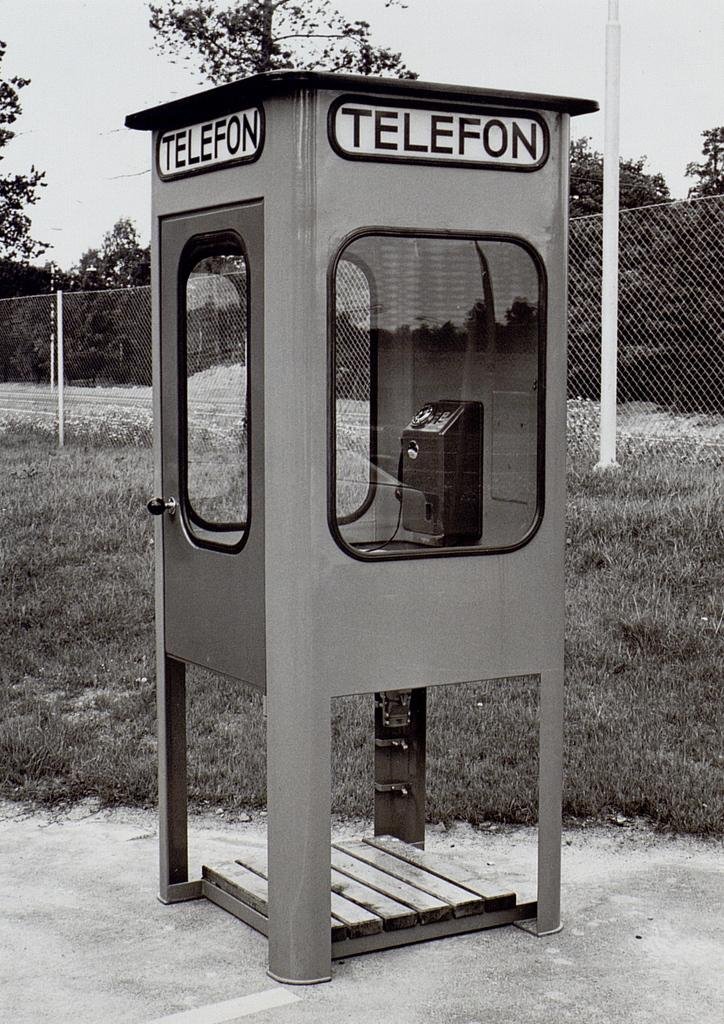<image>
Relay a brief, clear account of the picture shown. An old booth displayed in the middle of a park with a bold sign TELEFON on the top. 